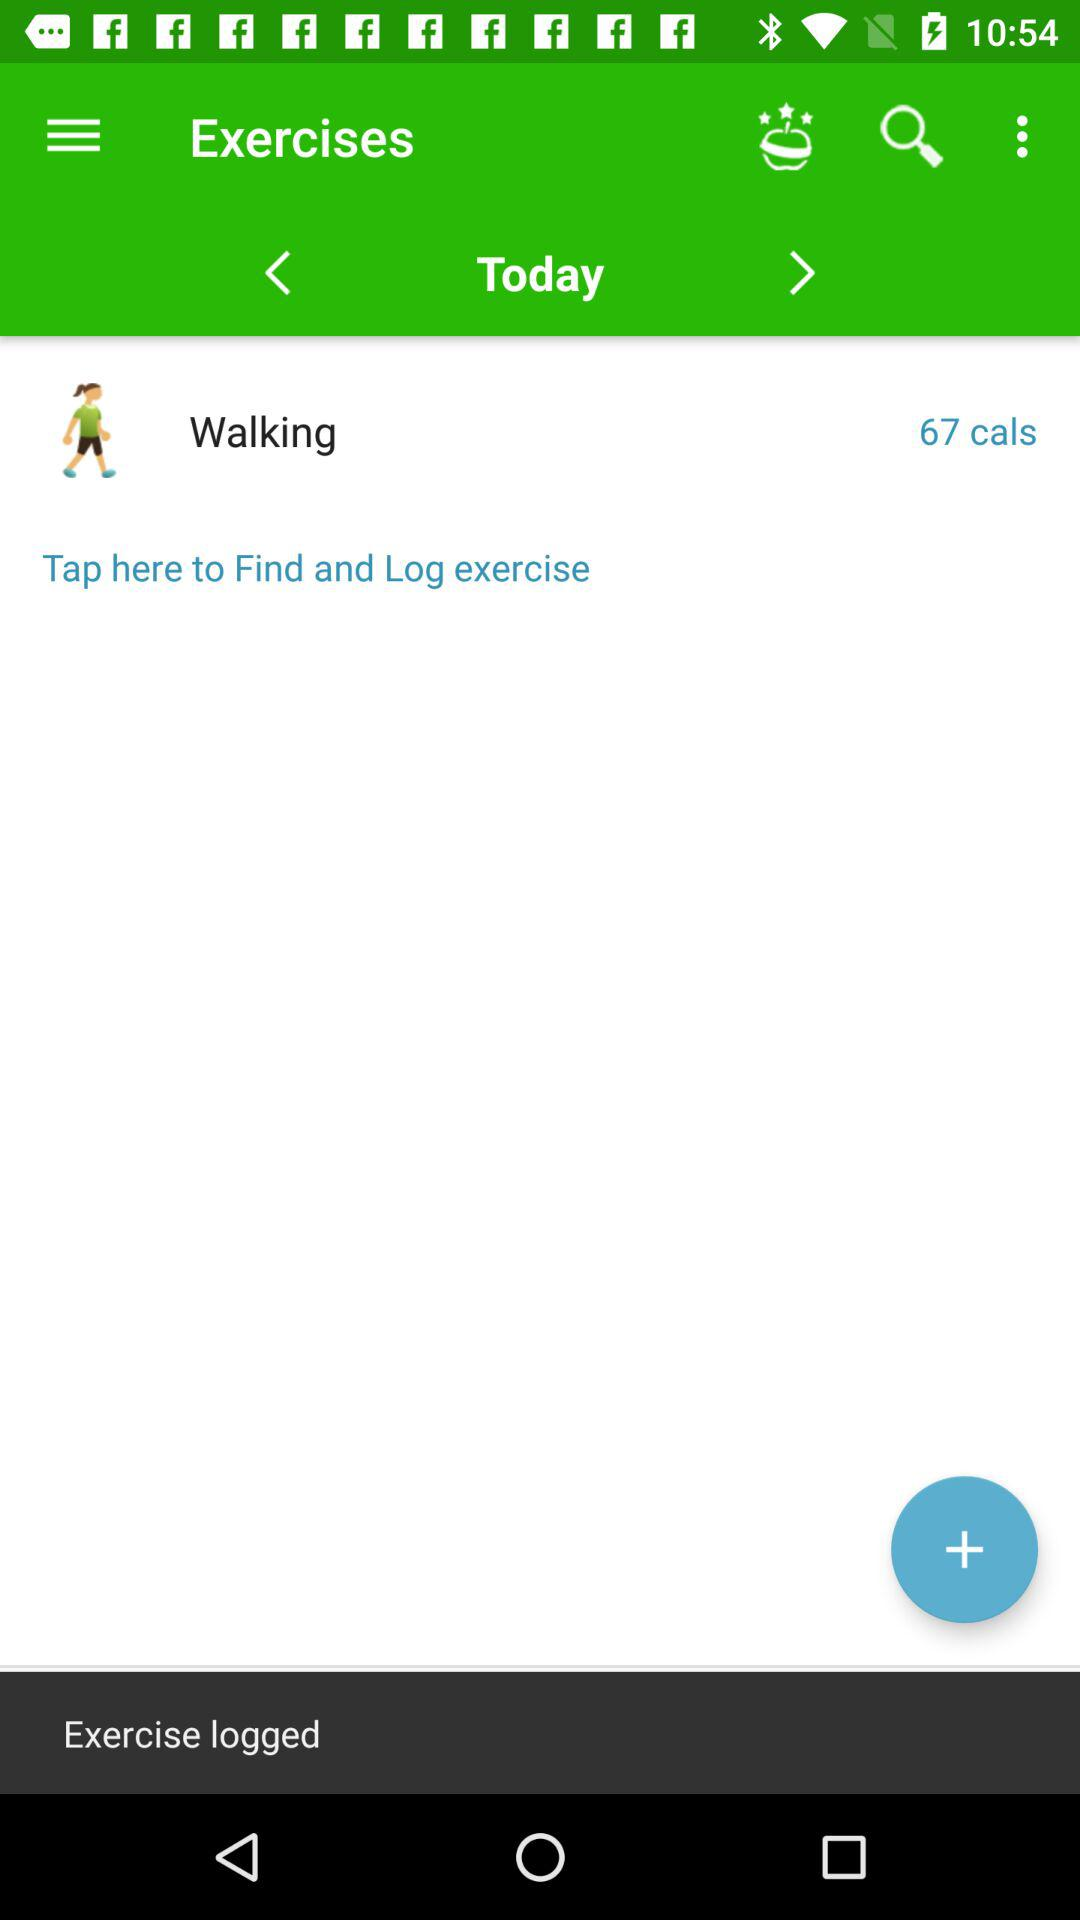How many calories did I burn walking?
Answer the question using a single word or phrase. 67 